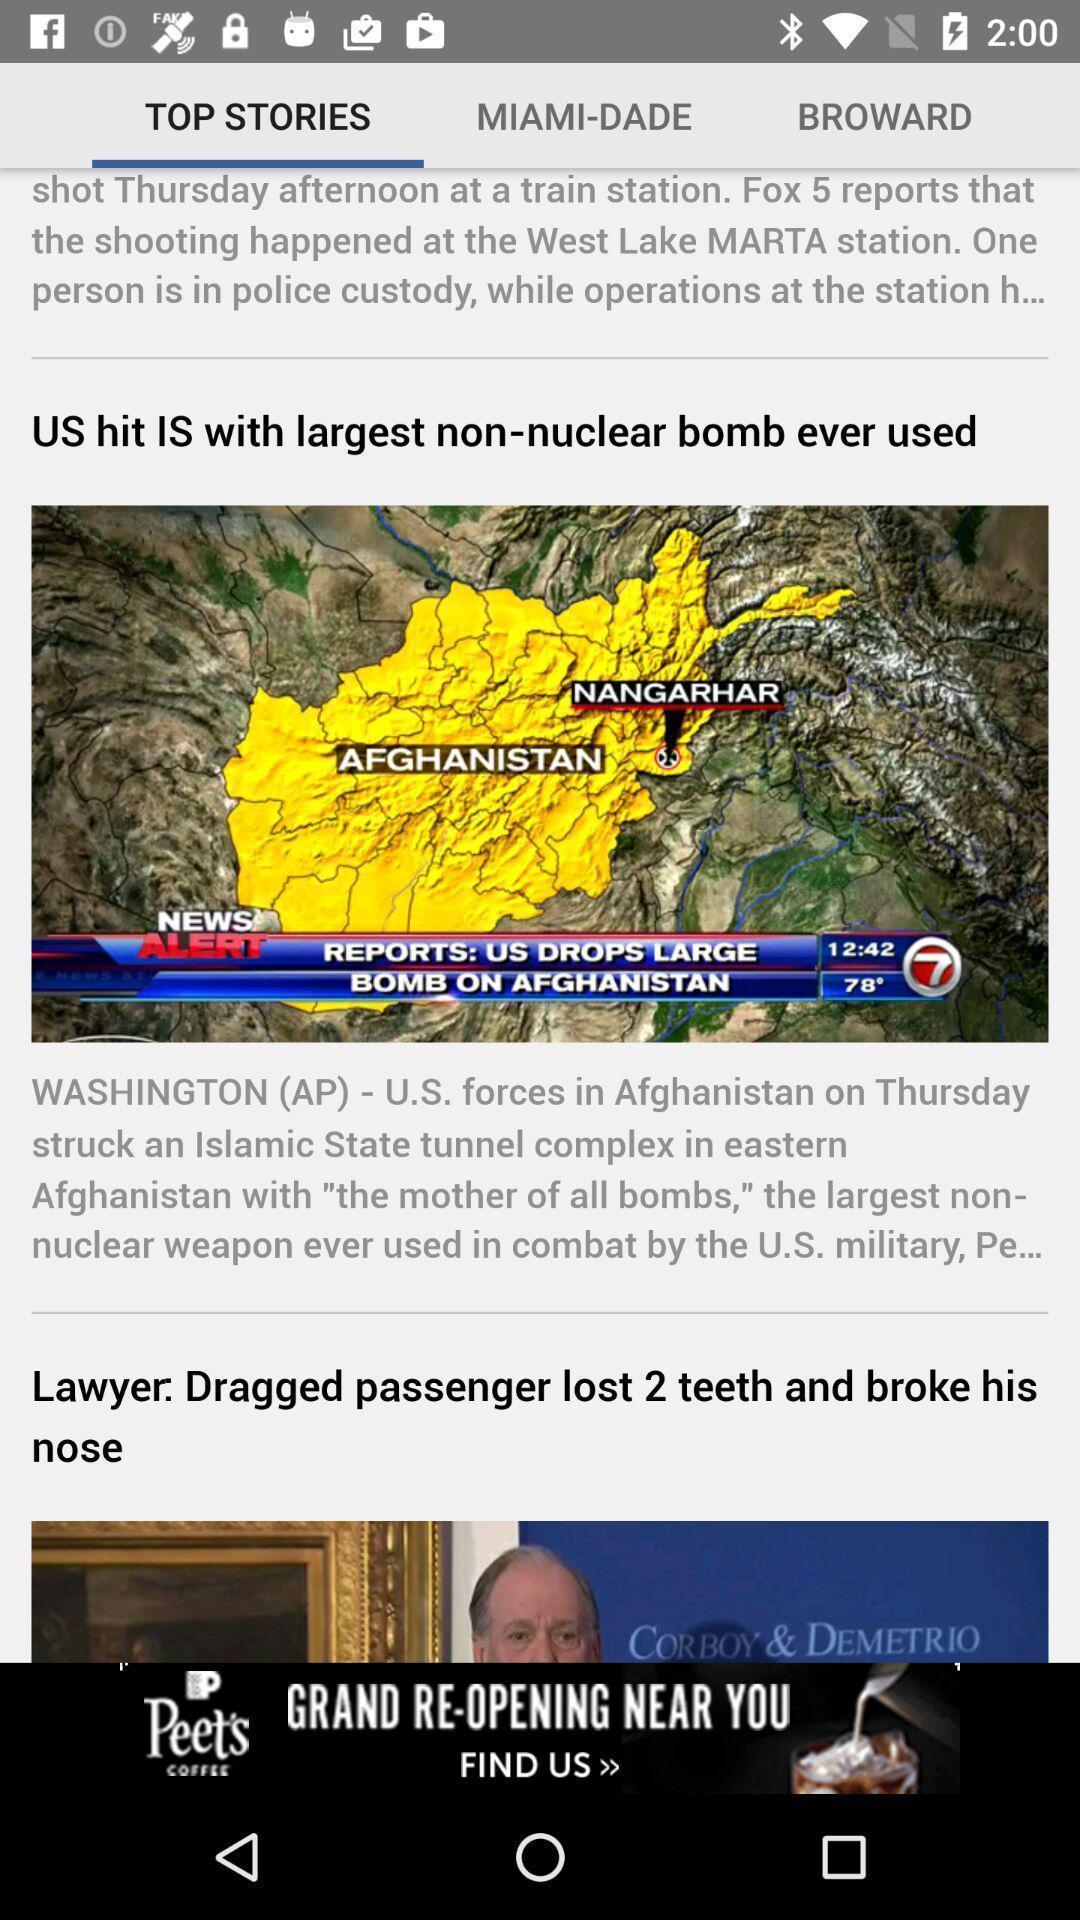Tell me about the visual elements in this screen capture. Screen display top stories page of a news app. 